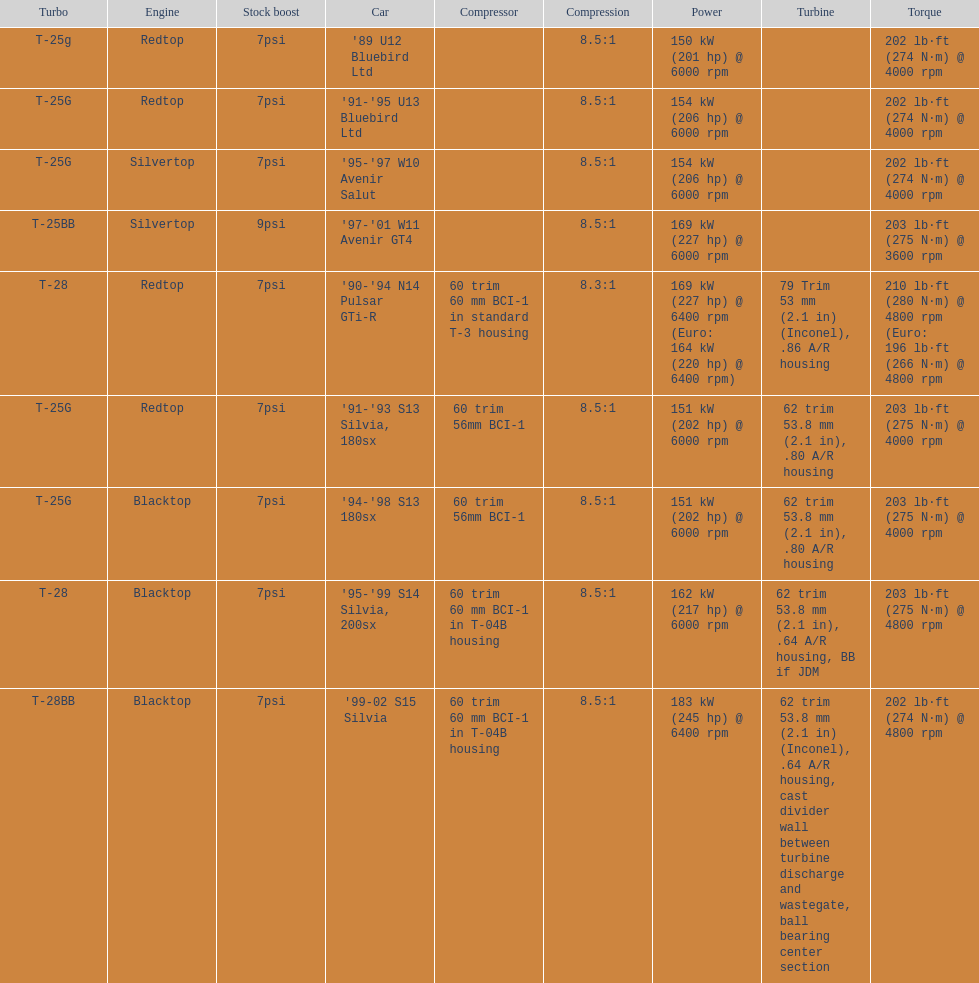Which car's power measured at higher than 6000 rpm? '90-'94 N14 Pulsar GTi-R, '99-02 S15 Silvia. 